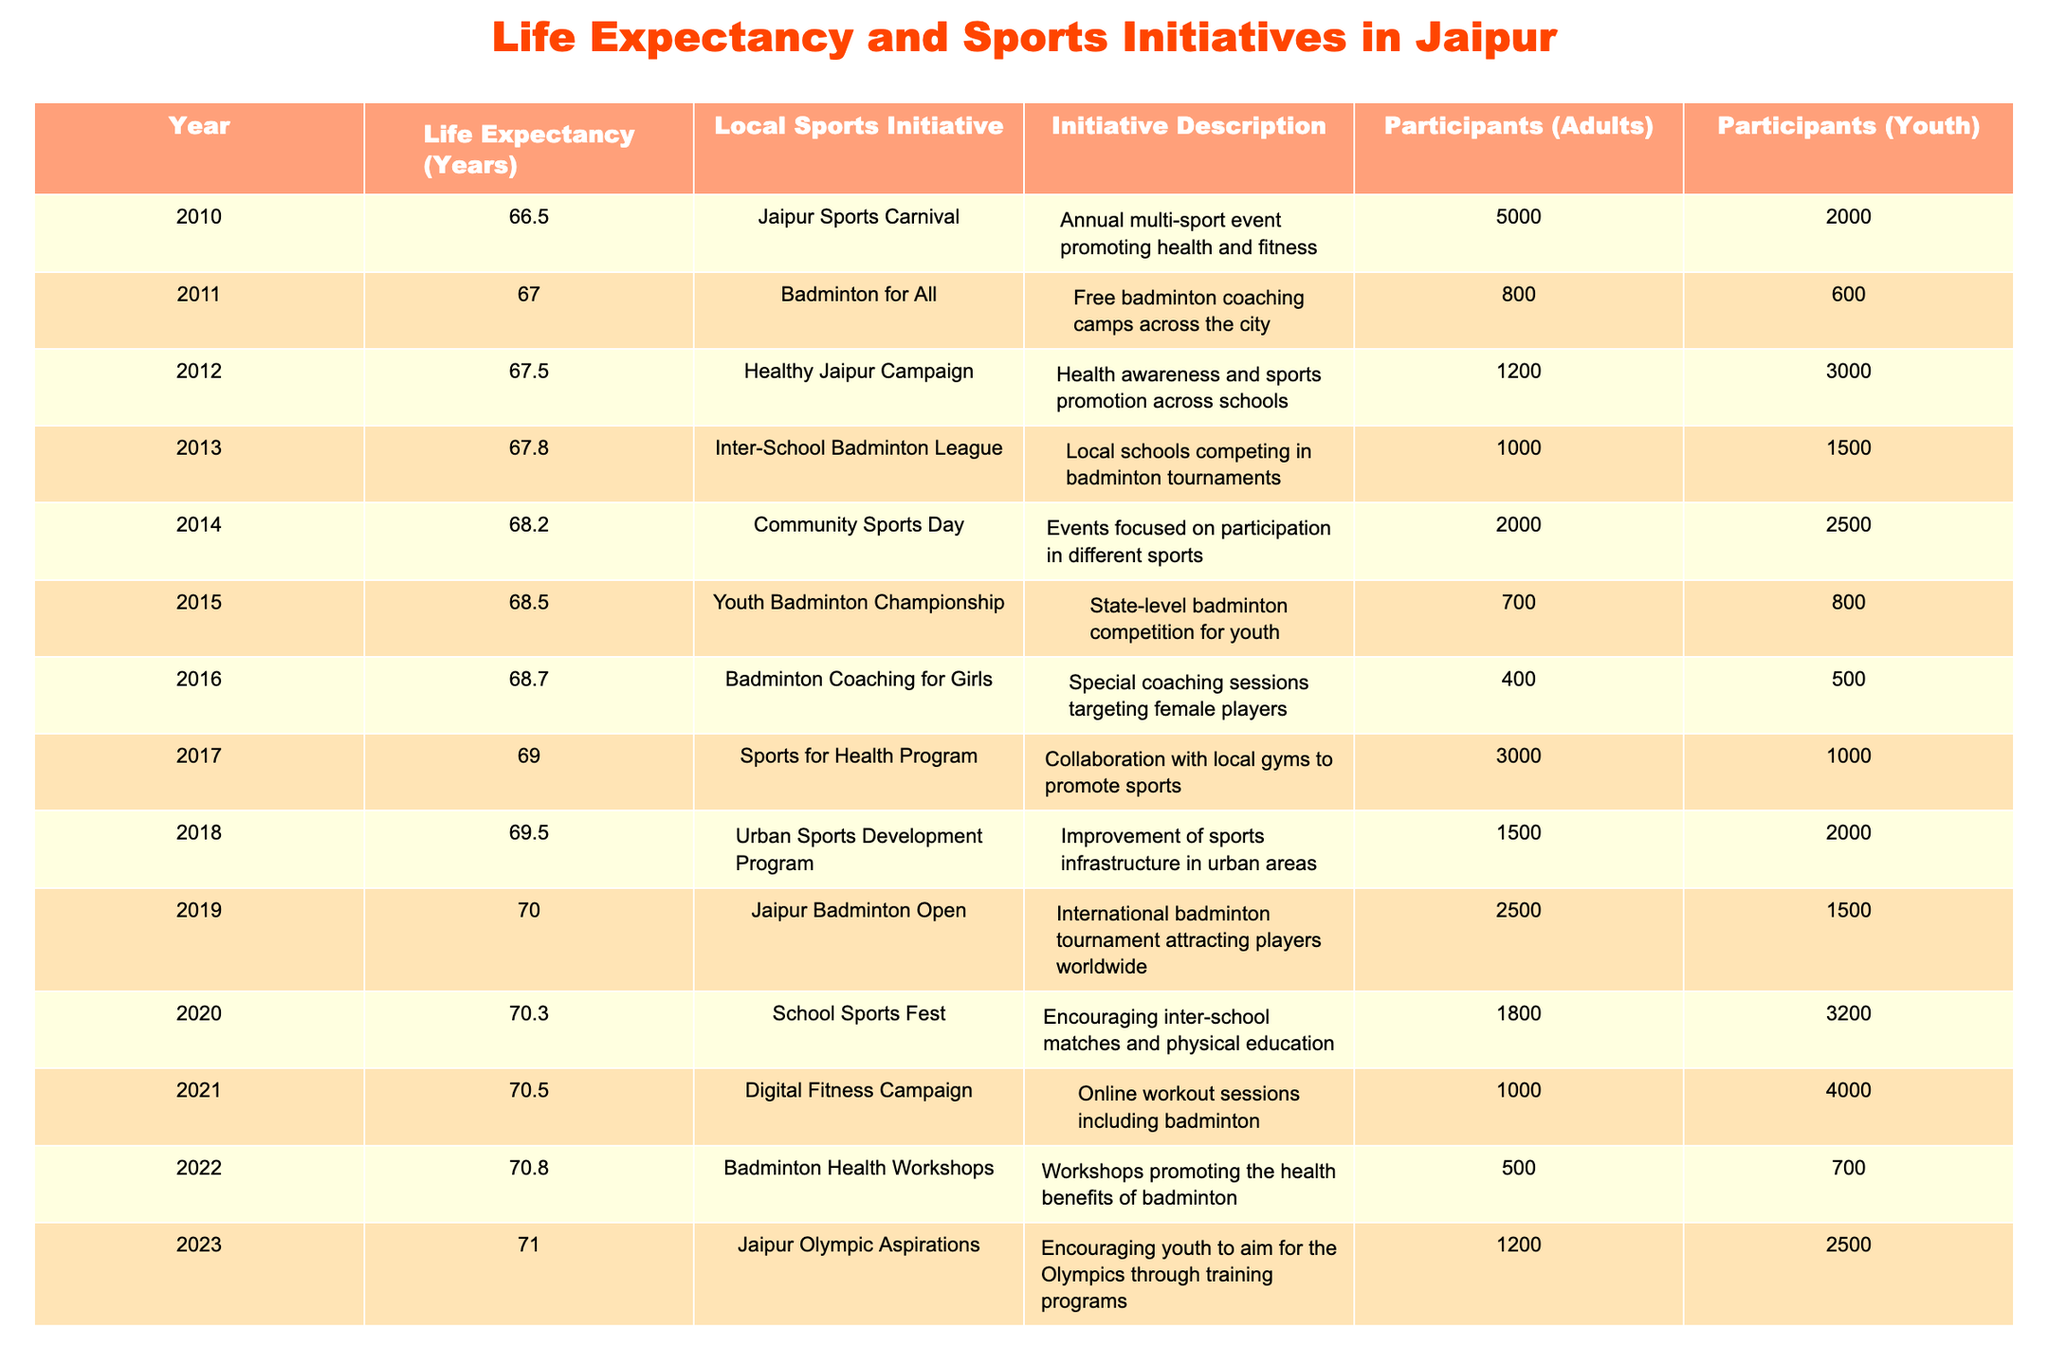What was the life expectancy in Jaipur in 2015? The life expectancy for Jaipur in 2015 is directly mentioned in the table under the corresponding year, which shows 68.5 years.
Answer: 68.5 What was the local sports initiative in 2019? The table indicates that the local sports initiative in 2019 was the "Jaipur Badminton Open."
Answer: Jaipur Badminton Open What is the total number of participants (adults) in the years 2012 and 2013 combined? To find this, we add the number of participants (adults) in 2012 (1200) and 2013 (1000), therefore the total is 1200 + 1000 = 2200 participants.
Answer: 2200 Did the life expectancy in Jaipur increase every year from 2010 to 2023? By examining the table, we can see that life expectancy consistently increased from 66.5 in 2010 to 71.0 in 2023, confirming that it increased each year.
Answer: Yes What is the average number of adult participants across all initiatives from 2010 to 2023? To calculate the average, we first sum the number of adult participants from each year: (5000 + 800 + 1200 + 1000 + 2000 + 700 + 400 + 3000 + 1500 + 2500 + 1800 + 1000 + 500 + 1200) = 20410. There are 14 data points divided by 14 gives an average of approximately 1450.
Answer: 1450 What was the highest life expectancy recorded in the years between 2010 and 2023? The highest life expectancy recorded in the table is for the year 2023, which is 71.0 years.
Answer: 71.0 How many participants (youth) were involved in the "Badminton for All" initiative in 2011? The table shows clearly that the number of participants (youth) in the "Badminton for All" initiative in 2011 was 600.
Answer: 600 What was the life expectancy increase from 2010 to 2015? The increase in life expectancy from 2010 (66.5) to 2015 (68.5) can be calculated by subtracting the two values: 68.5 - 66.5 = 2.0 years increase.
Answer: 2.0 years 